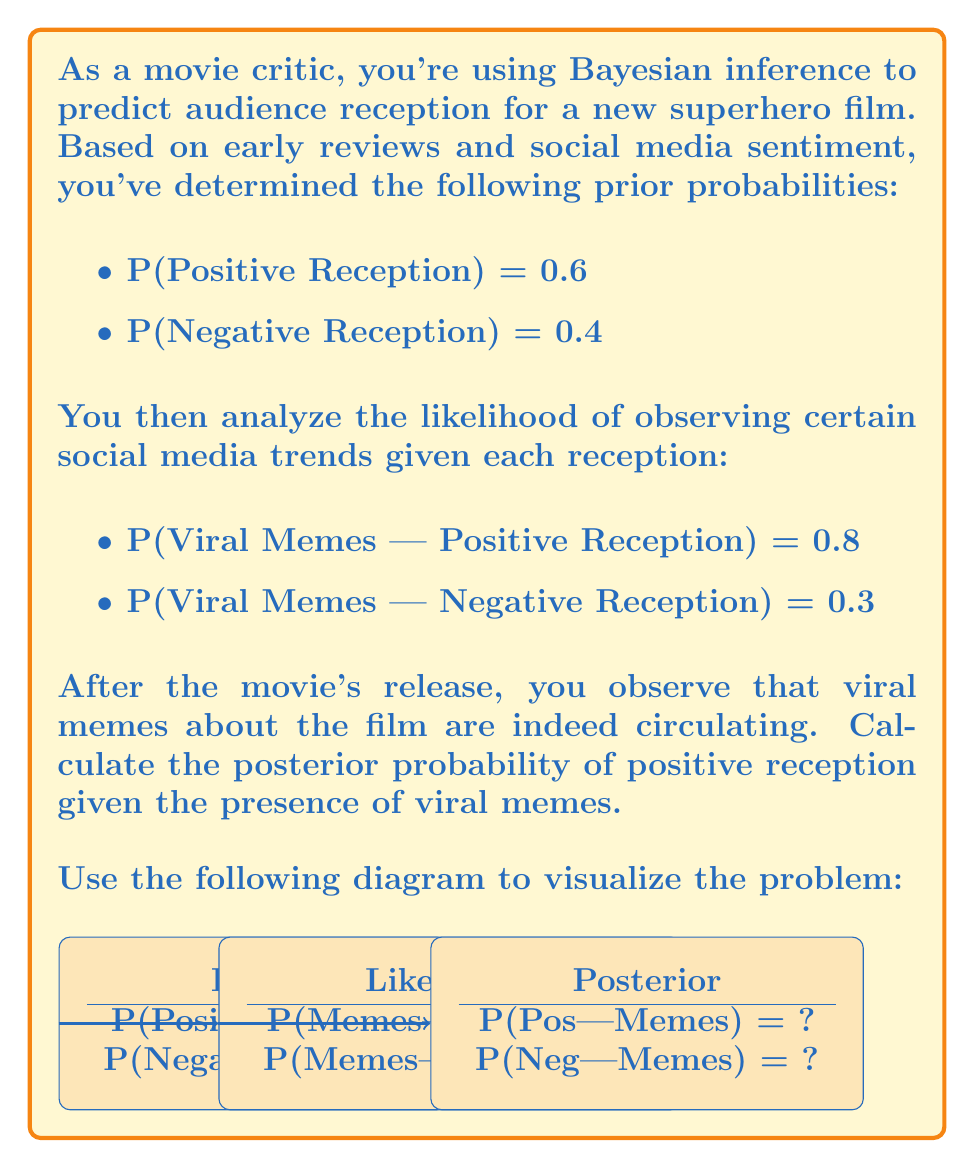Solve this math problem. To solve this problem, we'll use Bayes' theorem:

$$P(A|B) = \frac{P(B|A) \cdot P(A)}{P(B)}$$

Where:
A = Positive Reception
B = Viral Memes

Step 1: Identify the given probabilities
- P(A) = P(Positive Reception) = 0.6
- P(B|A) = P(Viral Memes | Positive Reception) = 0.8
- P(B|not A) = P(Viral Memes | Negative Reception) = 0.3
- P(not A) = P(Negative Reception) = 0.4

Step 2: Calculate P(B) using the law of total probability
$$P(B) = P(B|A) \cdot P(A) + P(B|not A) \cdot P(not A)$$
$$P(B) = 0.8 \cdot 0.6 + 0.3 \cdot 0.4 = 0.48 + 0.12 = 0.6$$

Step 3: Apply Bayes' theorem
$$P(A|B) = \frac{P(B|A) \cdot P(A)}{P(B)} = \frac{0.8 \cdot 0.6}{0.6} = 0.8$$

Therefore, the posterior probability of positive reception given the presence of viral memes is 0.8 or 80%.
Answer: 0.8 